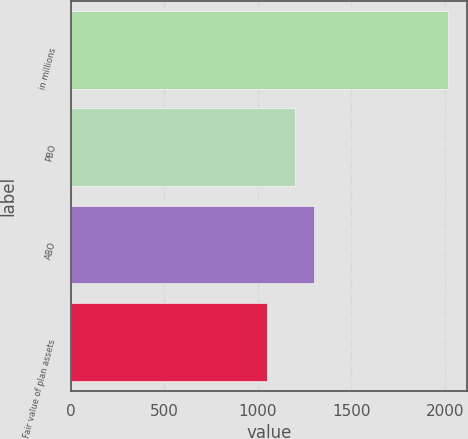Convert chart. <chart><loc_0><loc_0><loc_500><loc_500><bar_chart><fcel>in millions<fcel>PBO<fcel>ABO<fcel>Fair value of plan assets<nl><fcel>2018<fcel>1201<fcel>1298.2<fcel>1046<nl></chart> 